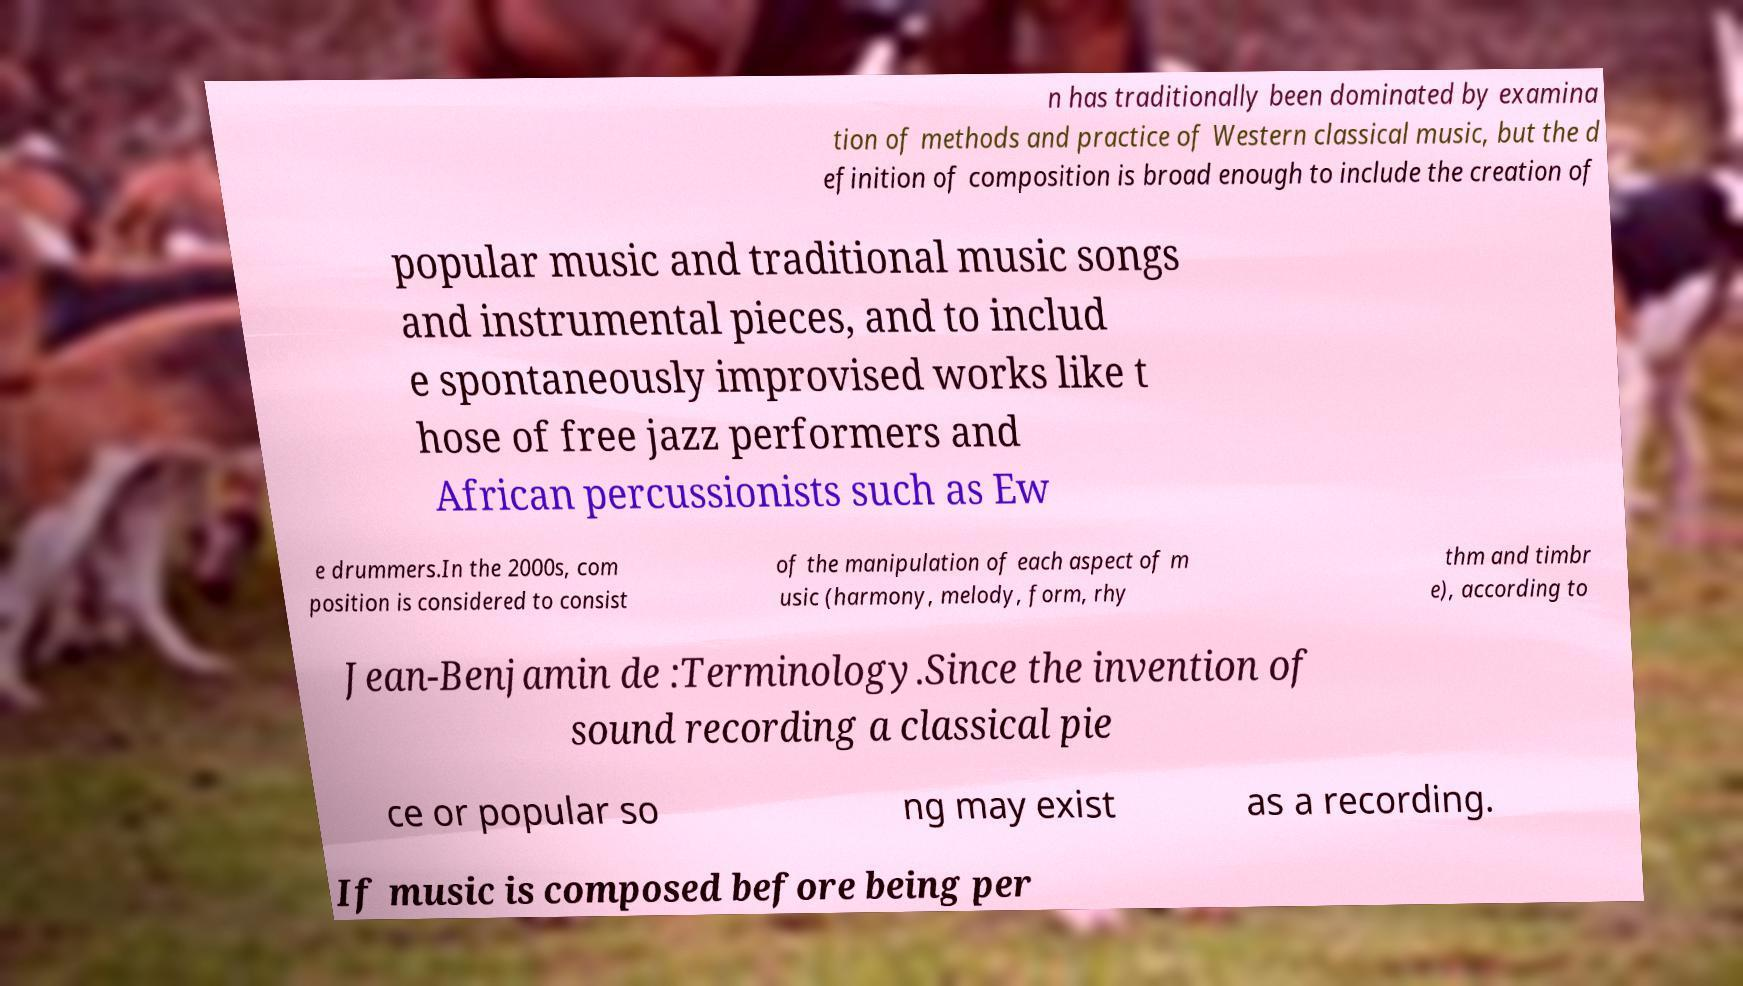Can you read and provide the text displayed in the image?This photo seems to have some interesting text. Can you extract and type it out for me? n has traditionally been dominated by examina tion of methods and practice of Western classical music, but the d efinition of composition is broad enough to include the creation of popular music and traditional music songs and instrumental pieces, and to includ e spontaneously improvised works like t hose of free jazz performers and African percussionists such as Ew e drummers.In the 2000s, com position is considered to consist of the manipulation of each aspect of m usic (harmony, melody, form, rhy thm and timbr e), according to Jean-Benjamin de :Terminology.Since the invention of sound recording a classical pie ce or popular so ng may exist as a recording. If music is composed before being per 